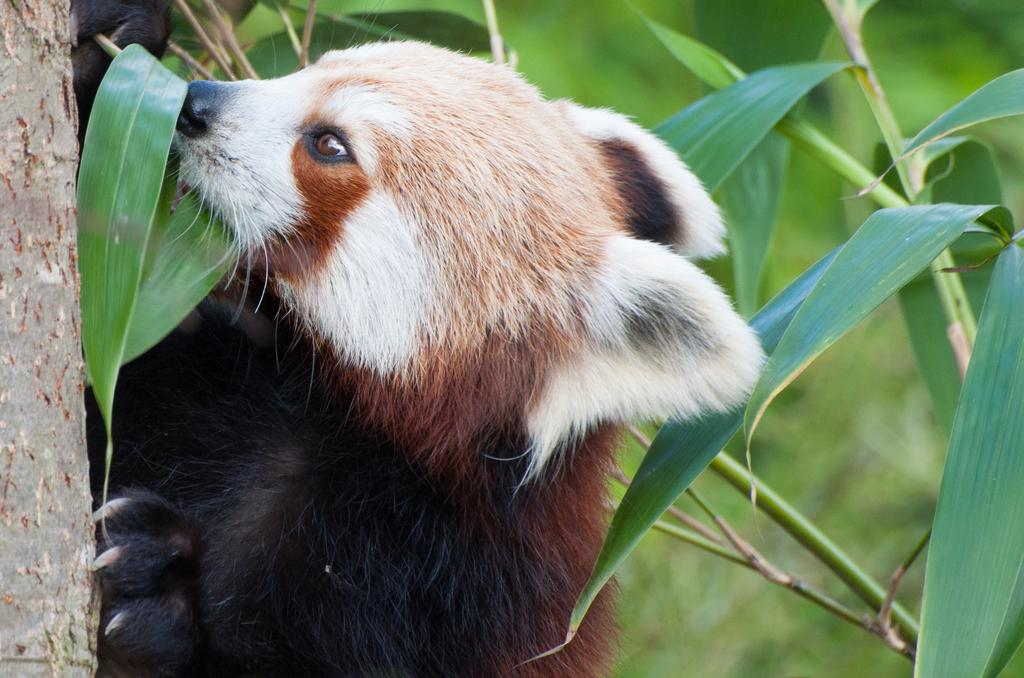What is the main subject in the center of the image? There is an animal in the center of the image. What type of vegetation can be seen on the right side of the image? Leaves are present on the right side of the image. What type of plant is visible on the left side of the image? A tree is present on the left side of the image. What advice does the father give to the animal in the image? There is no father present in the image, so no advice can be given. 